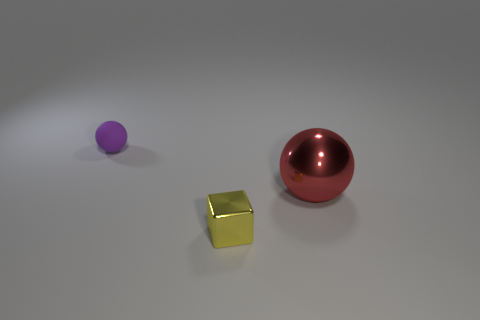Add 1 purple rubber spheres. How many objects exist? 4 Subtract all balls. How many objects are left? 1 Subtract 1 red balls. How many objects are left? 2 Subtract all tiny cyan balls. Subtract all tiny yellow objects. How many objects are left? 2 Add 1 large red spheres. How many large red spheres are left? 2 Add 1 small purple objects. How many small purple objects exist? 2 